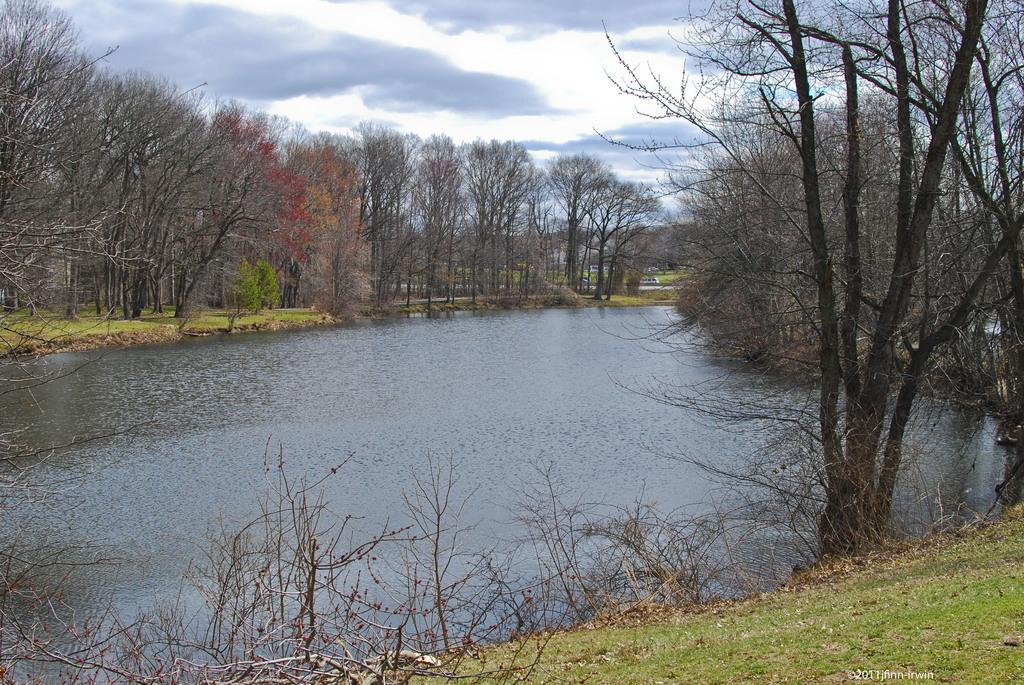What type of vegetation can be seen in the image? There are trees in the image, extending from left to right. What else can be seen besides trees in the image? There is water visible in the image. What is covering the ground in the image? Grass is present on the ground. What is the condition of the sky in the image? The sky is cloudy. What type of bread and jam can be seen in the image? There is no bread or jam present in the image. 